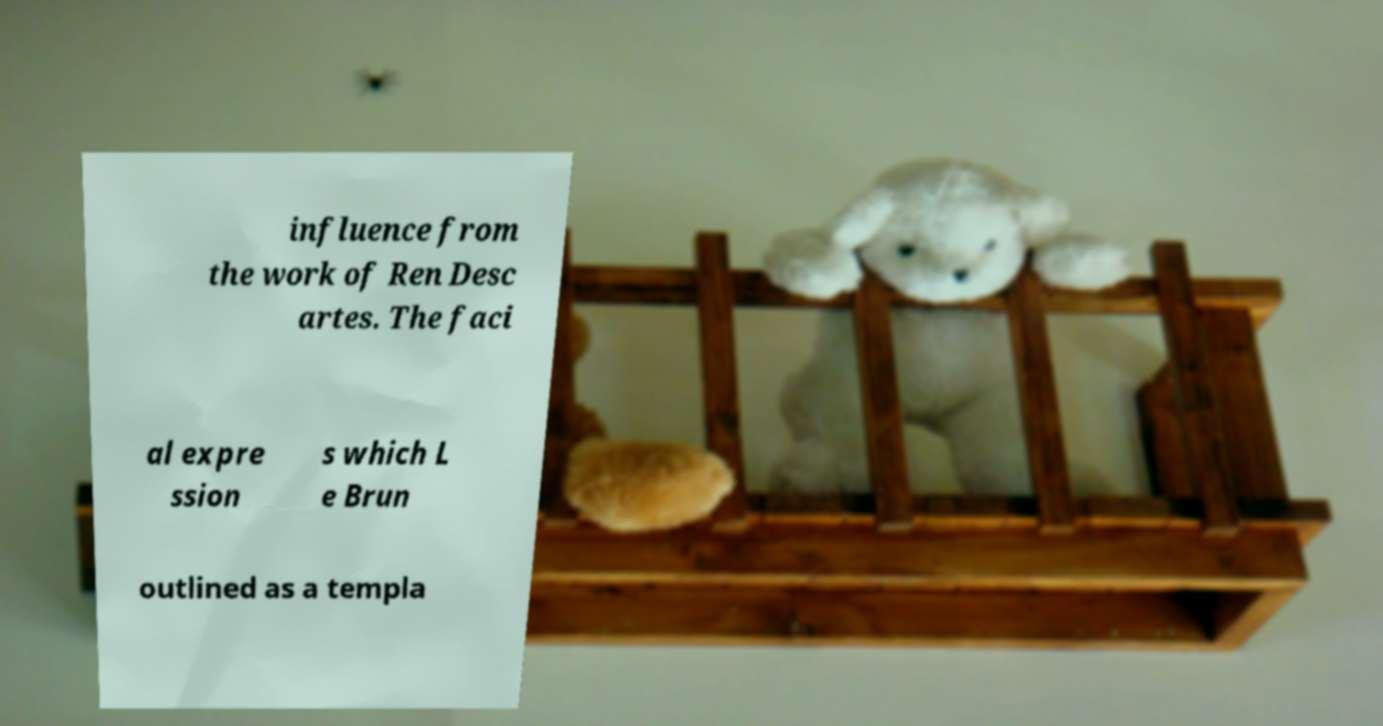Could you assist in decoding the text presented in this image and type it out clearly? influence from the work of Ren Desc artes. The faci al expre ssion s which L e Brun outlined as a templa 